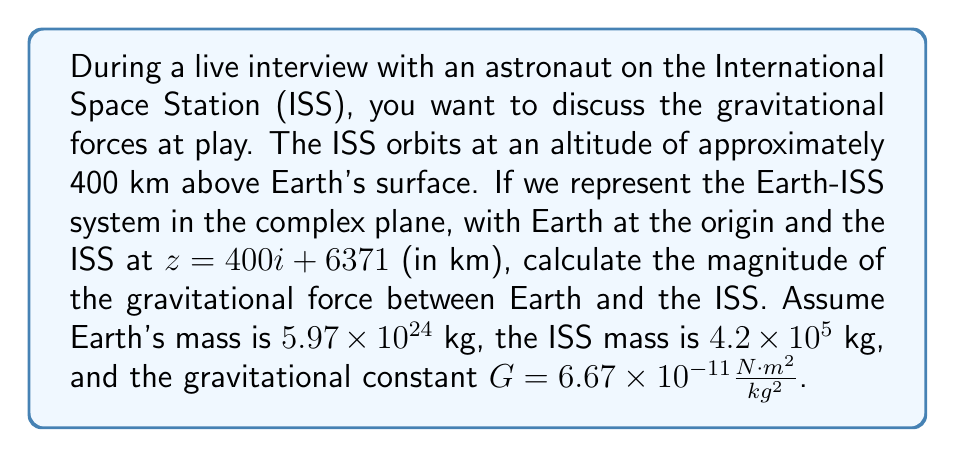Could you help me with this problem? To solve this problem, we'll follow these steps:

1) First, let's calculate the distance between Earth and the ISS using the complex number representation:

   $z = 400i + 6371$
   
   Distance = $|z| = \sqrt{400^2 + 6371^2} = \sqrt{160000 + 40589641} = \sqrt{40749641} \approx 6782.33$ km

2) Convert this distance to meters:
   
   $6782.33$ km $= 6782330$ m

3) Now, we can use Newton's law of universal gravitation:

   $F = G \frac{m_1 m_2}{r^2}$

   Where:
   $G = 6.67 \times 10^{-11} \frac{N \cdot m^2}{kg^2}$
   $m_1 = 5.97 \times 10^{24}$ kg (Earth's mass)
   $m_2 = 4.2 \times 10^5$ kg (ISS mass)
   $r = 6782330$ m

4) Let's substitute these values:

   $F = (6.67 \times 10^{-11}) \frac{(5.97 \times 10^{24})(4.2 \times 10^5)}{(6782330)^2}$

5) Simplify:

   $F = \frac{(6.67 \times 5.97 \times 4.2) \times (10^{-11} \times 10^{24} \times 10^5)}{(6782330)^2}$

   $F = \frac{167.21 \times 10^{18}}{46000012288900}$

6) Calculate the final result:

   $F \approx 3635.87$ N

Therefore, the magnitude of the gravitational force between Earth and the ISS is approximately 3635.87 N.
Answer: $3635.87$ N 